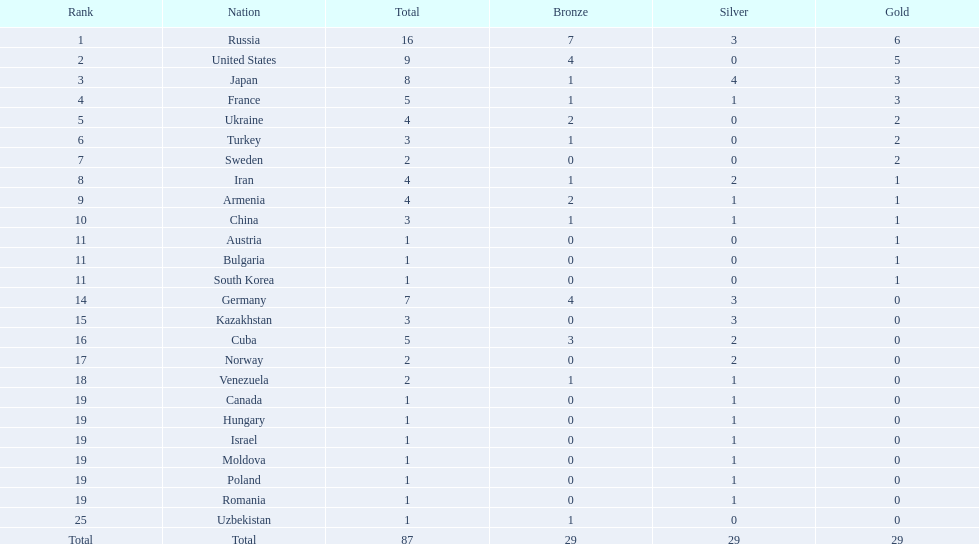Which countries competed in the 1995 world wrestling championships? Russia, United States, Japan, France, Ukraine, Turkey, Sweden, Iran, Armenia, China, Austria, Bulgaria, South Korea, Germany, Kazakhstan, Cuba, Norway, Venezuela, Canada, Hungary, Israel, Moldova, Poland, Romania, Uzbekistan. What country won only one medal? Austria, Bulgaria, South Korea, Canada, Hungary, Israel, Moldova, Poland, Romania, Uzbekistan. Which of these won a bronze medal? Uzbekistan. 